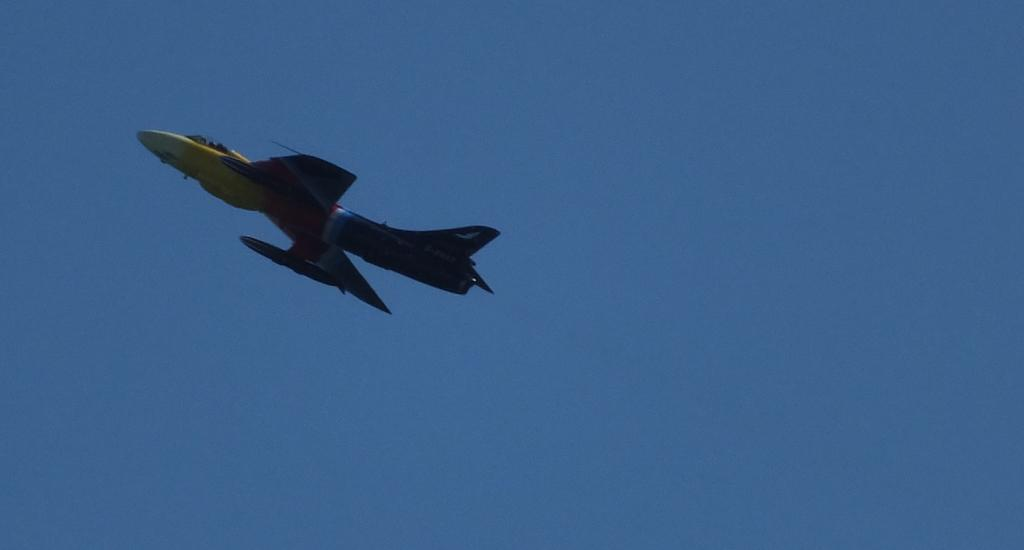What is the main subject of the image? There is an aircraft in the image. What is the aircraft doing in the image? The aircraft is flying in the air. What can be seen in the background of the image? The sky is visible in the background of the image. What is the color of the sky in the image? The color of the sky is blue. What type of joke can be heard coming from the aircraft in the image? There is no indication in the image that a joke is being told or heard, as the image only shows an aircraft flying in the air. 